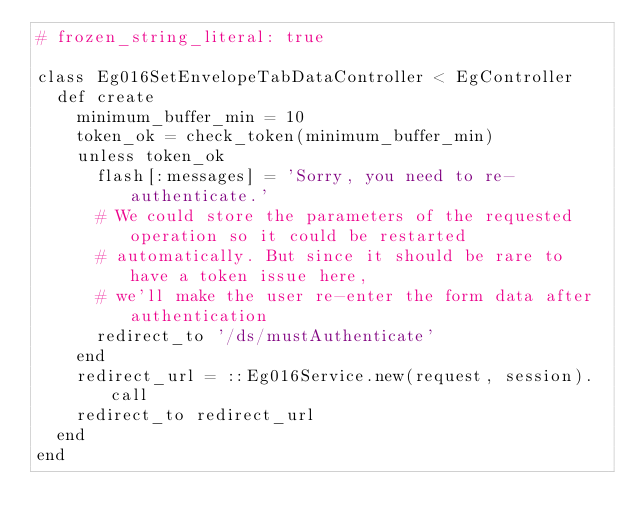Convert code to text. <code><loc_0><loc_0><loc_500><loc_500><_Ruby_># frozen_string_literal: true

class Eg016SetEnvelopeTabDataController < EgController
  def create
    minimum_buffer_min = 10
    token_ok = check_token(minimum_buffer_min)
    unless token_ok
      flash[:messages] = 'Sorry, you need to re-authenticate.'
      # We could store the parameters of the requested operation so it could be restarted
      # automatically. But since it should be rare to have a token issue here,
      # we'll make the user re-enter the form data after authentication
      redirect_to '/ds/mustAuthenticate'
    end
    redirect_url = ::Eg016Service.new(request, session).call
    redirect_to redirect_url
  end
end
</code> 